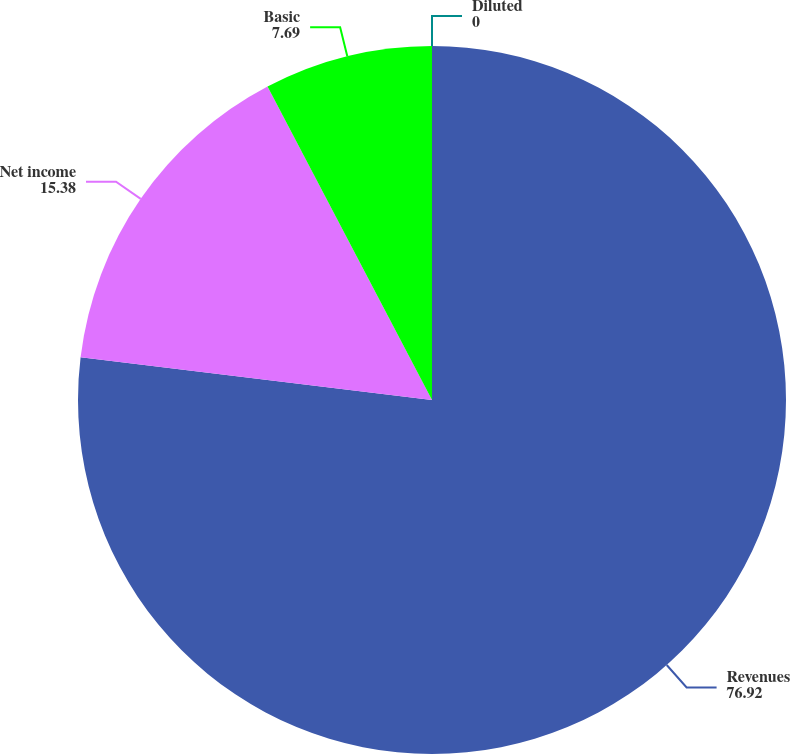Convert chart. <chart><loc_0><loc_0><loc_500><loc_500><pie_chart><fcel>Revenues<fcel>Net income<fcel>Basic<fcel>Diluted<nl><fcel>76.92%<fcel>15.38%<fcel>7.69%<fcel>0.0%<nl></chart> 